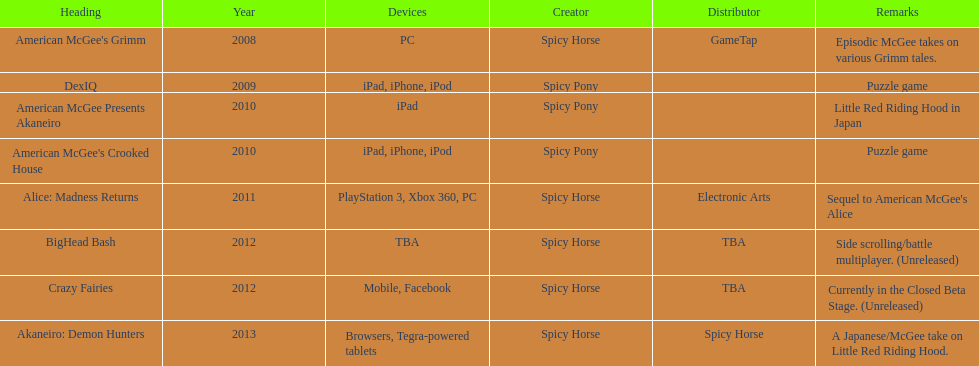Help me parse the entirety of this table. {'header': ['Heading', 'Year', 'Devices', 'Creator', 'Distributor', 'Remarks'], 'rows': [["American McGee's Grimm", '2008', 'PC', 'Spicy Horse', 'GameTap', 'Episodic McGee takes on various Grimm tales.'], ['DexIQ', '2009', 'iPad, iPhone, iPod', 'Spicy Pony', '', 'Puzzle game'], ['American McGee Presents Akaneiro', '2010', 'iPad', 'Spicy Pony', '', 'Little Red Riding Hood in Japan'], ["American McGee's Crooked House", '2010', 'iPad, iPhone, iPod', 'Spicy Pony', '', 'Puzzle game'], ['Alice: Madness Returns', '2011', 'PlayStation 3, Xbox 360, PC', 'Spicy Horse', 'Electronic Arts', "Sequel to American McGee's Alice"], ['BigHead Bash', '2012', 'TBA', 'Spicy Horse', 'TBA', 'Side scrolling/battle multiplayer. (Unreleased)'], ['Crazy Fairies', '2012', 'Mobile, Facebook', 'Spicy Horse', 'TBA', 'Currently in the Closed Beta Stage. (Unreleased)'], ['Akaneiro: Demon Hunters', '2013', 'Browsers, Tegra-powered tablets', 'Spicy Horse', 'Spicy Horse', 'A Japanese/McGee take on Little Red Riding Hood.']]} What was the last game created by spicy horse Akaneiro: Demon Hunters. 